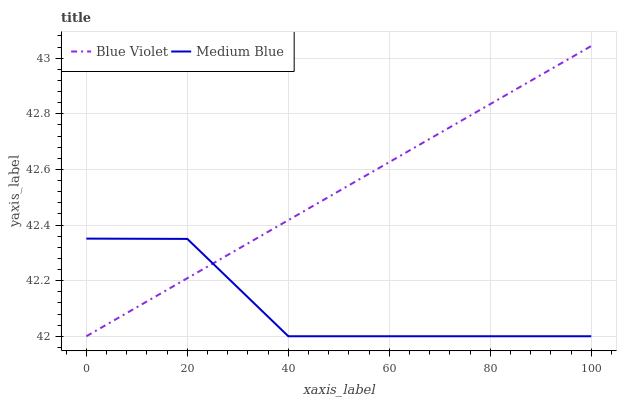Does Medium Blue have the minimum area under the curve?
Answer yes or no. Yes. Does Blue Violet have the maximum area under the curve?
Answer yes or no. Yes. Does Blue Violet have the minimum area under the curve?
Answer yes or no. No. Is Blue Violet the smoothest?
Answer yes or no. Yes. Is Medium Blue the roughest?
Answer yes or no. Yes. Is Blue Violet the roughest?
Answer yes or no. No. Does Medium Blue have the lowest value?
Answer yes or no. Yes. Does Blue Violet have the highest value?
Answer yes or no. Yes. Does Medium Blue intersect Blue Violet?
Answer yes or no. Yes. Is Medium Blue less than Blue Violet?
Answer yes or no. No. Is Medium Blue greater than Blue Violet?
Answer yes or no. No. 